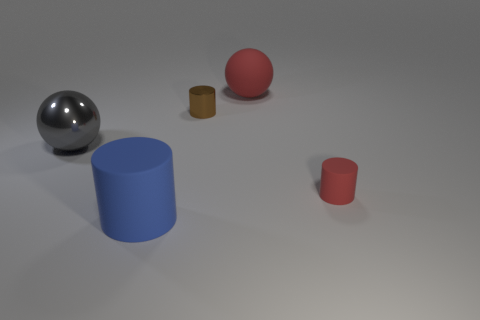Subtract all large rubber cylinders. How many cylinders are left? 2 Subtract 1 cylinders. How many cylinders are left? 2 Subtract all gray cylinders. Subtract all gray blocks. How many cylinders are left? 3 Add 5 blue cylinders. How many objects exist? 10 Subtract all cylinders. How many objects are left? 2 Add 1 rubber things. How many rubber things exist? 4 Subtract 0 purple cubes. How many objects are left? 5 Subtract all large spheres. Subtract all small cylinders. How many objects are left? 1 Add 4 large red things. How many large red things are left? 5 